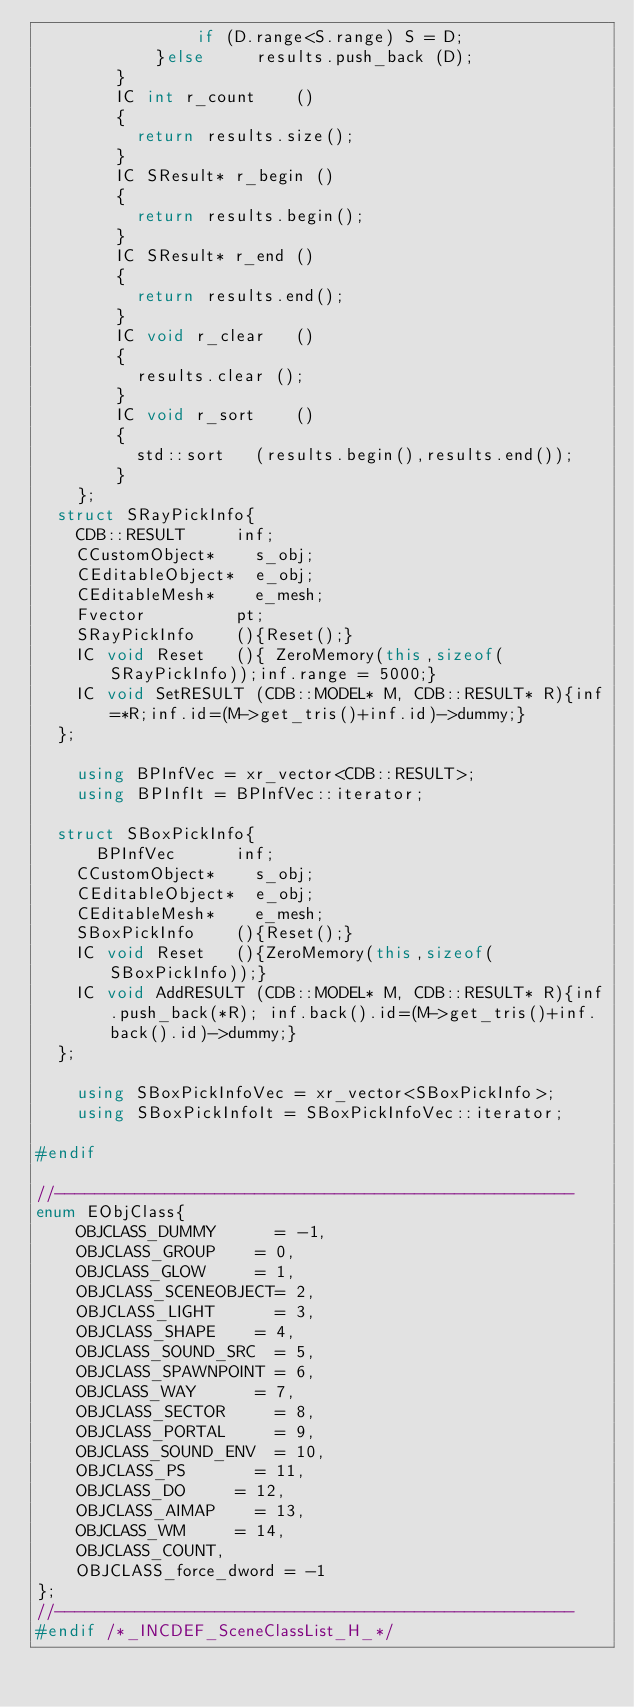Convert code to text. <code><loc_0><loc_0><loc_500><loc_500><_C++_>                if (D.range<S.range) S = D;
            }else			results.push_back	(D);
        }
        IC int r_count		()
        {
        	return results.size();
        }
        IC SResult* r_begin	()
        {
        	return results.begin();
        }
        IC SResult* r_end	()
        {
        	return results.end();
        }
        IC void r_clear		()
        {
        	results.clear	();
        }
        IC void r_sort		()
        {
        	std::sort		(results.begin(),results.end());
        }
    };
	struct SRayPickInfo{
		CDB::RESULT 		inf;
		CCustomObject*		s_obj;
		CEditableObject*	e_obj;
		CEditableMesh*		e_mesh;
		Fvector     		pt;
		SRayPickInfo		(){Reset();}
		IC void Reset		(){ ZeroMemory(this,sizeof(SRayPickInfo));inf.range = 5000;}
		IC void SetRESULT	(CDB::MODEL* M, CDB::RESULT* R){inf=*R;inf.id=(M->get_tris()+inf.id)->dummy;}
	};
    
    using BPInfVec = xr_vector<CDB::RESULT>;
    using BPInfIt = BPInfVec::iterator;

	struct SBoxPickInfo{
    	BPInfVec			inf;
		CCustomObject*		s_obj;
		CEditableObject*	e_obj;
		CEditableMesh*		e_mesh;
		SBoxPickInfo		(){Reset();}
		IC void Reset		(){ZeroMemory(this,sizeof(SBoxPickInfo));}
		IC void AddRESULT	(CDB::MODEL* M, CDB::RESULT* R){inf.push_back(*R); inf.back().id=(M->get_tris()+inf.back().id)->dummy;}
	};
	
    using SBoxPickInfoVec = xr_vector<SBoxPickInfo>;
    using SBoxPickInfoIt = SBoxPickInfoVec::iterator;
    
#endif

//----------------------------------------------------
enum EObjClass{
    OBJCLASS_DUMMY     	= -1,
    OBJCLASS_GROUP		= 0,
    OBJCLASS_GLOW	   	= 1,
    OBJCLASS_SCENEOBJECT= 2,
    OBJCLASS_LIGHT	   	= 3,
    OBJCLASS_SHAPE  	= 4,
    OBJCLASS_SOUND_SRC 	= 5,
    OBJCLASS_SPAWNPOINT	= 6,
    OBJCLASS_WAY	  	= 7,
    OBJCLASS_SECTOR    	= 8,
    OBJCLASS_PORTAL    	= 9,
    OBJCLASS_SOUND_ENV 	= 10,
    OBJCLASS_PS		   	= 11,
    OBJCLASS_DO			= 12,
    OBJCLASS_AIMAP		= 13,
    OBJCLASS_WM			= 14,
    OBJCLASS_COUNT,
    OBJCLASS_force_dword = -1
};
//----------------------------------------------------
#endif /*_INCDEF_SceneClassList_H_*/


</code> 